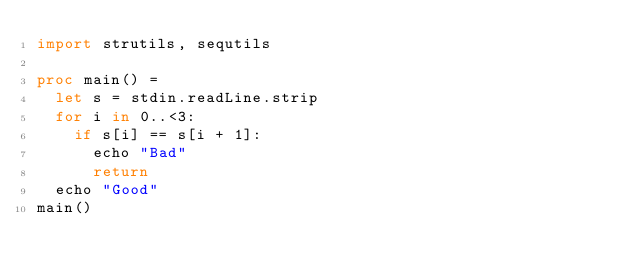Convert code to text. <code><loc_0><loc_0><loc_500><loc_500><_Nim_>import strutils, sequtils

proc main() =
  let s = stdin.readLine.strip
  for i in 0..<3:
    if s[i] == s[i + 1]:
      echo "Bad"
      return
  echo "Good"
main()
</code> 